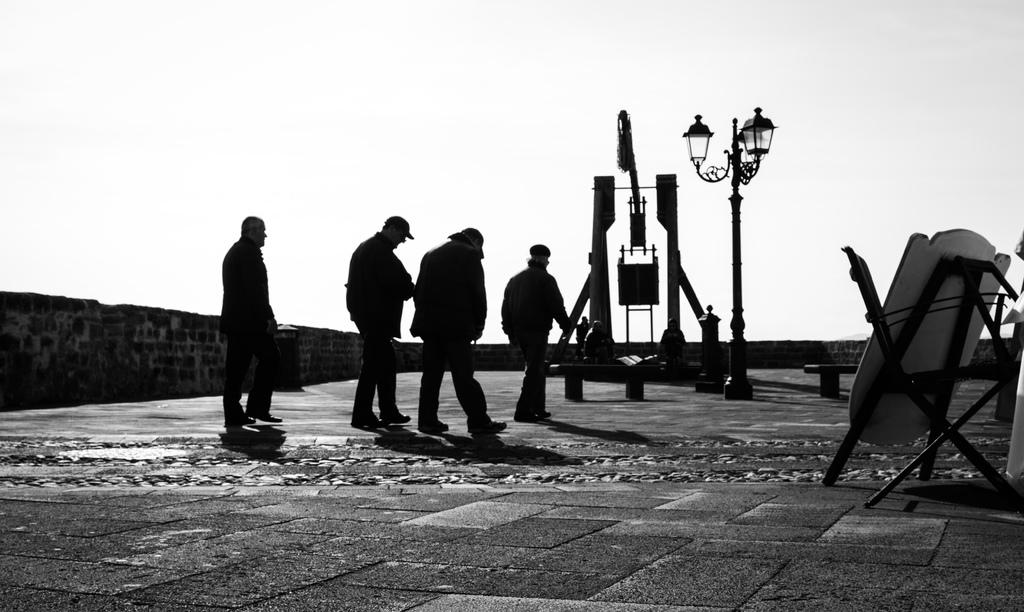What are the people in the image doing? The people in the image are walking in the center of the image. What is located in the center of the image besides the people? There is a pole in the center of the image. What can be seen on the right side of the image? There is a board on the right side of the image. What is visible in the background of the image? The sky and a tower are visible in the background of the image. What architectural feature is present in the background? There is a wall in the background of the image. Can you tell me how many quilts are hanging on the wall in the image? There are no quilts present in the image; the wall is visible in the background, but no quilts are hanging on it. Is the person's uncle mentioned or visible in the image? There is no mention or visibility of an uncle in the image. 